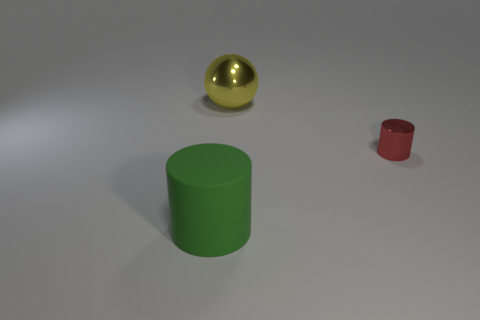There is a large object that is behind the large green object; is there a yellow shiny object that is on the right side of it?
Your answer should be very brief. No. Is there a blue block that has the same material as the large green cylinder?
Give a very brief answer. No. The cylinder that is in front of the cylinder that is on the right side of the big rubber cylinder is made of what material?
Give a very brief answer. Rubber. What material is the object that is in front of the large yellow thing and left of the small shiny object?
Offer a very short reply. Rubber. Are there the same number of small red metal things that are on the left side of the large green rubber cylinder and small metallic things?
Your answer should be compact. No. What number of other small yellow shiny objects have the same shape as the tiny metallic thing?
Give a very brief answer. 0. What is the size of the cylinder on the right side of the shiny object to the left of the object on the right side of the yellow thing?
Give a very brief answer. Small. Does the big thing that is behind the big green matte object have the same material as the tiny cylinder?
Keep it short and to the point. Yes. Are there the same number of big yellow metal spheres that are in front of the big yellow thing and small shiny objects behind the small red metallic cylinder?
Provide a succinct answer. Yes. Are there any other things that have the same size as the metallic cylinder?
Ensure brevity in your answer.  No. 